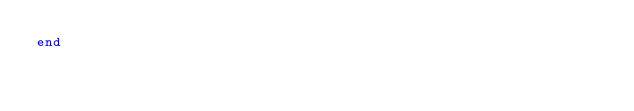<code> <loc_0><loc_0><loc_500><loc_500><_Ruby_>end
</code> 